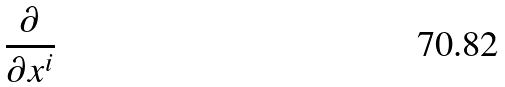Convert formula to latex. <formula><loc_0><loc_0><loc_500><loc_500>\frac { \partial } { \partial x ^ { i } }</formula> 